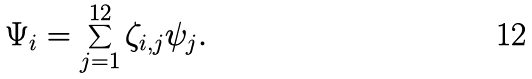Convert formula to latex. <formula><loc_0><loc_0><loc_500><loc_500>\Psi _ { i } = \sum _ { j = 1 } ^ { 1 2 } \zeta _ { i , j } \psi _ { j } .</formula> 